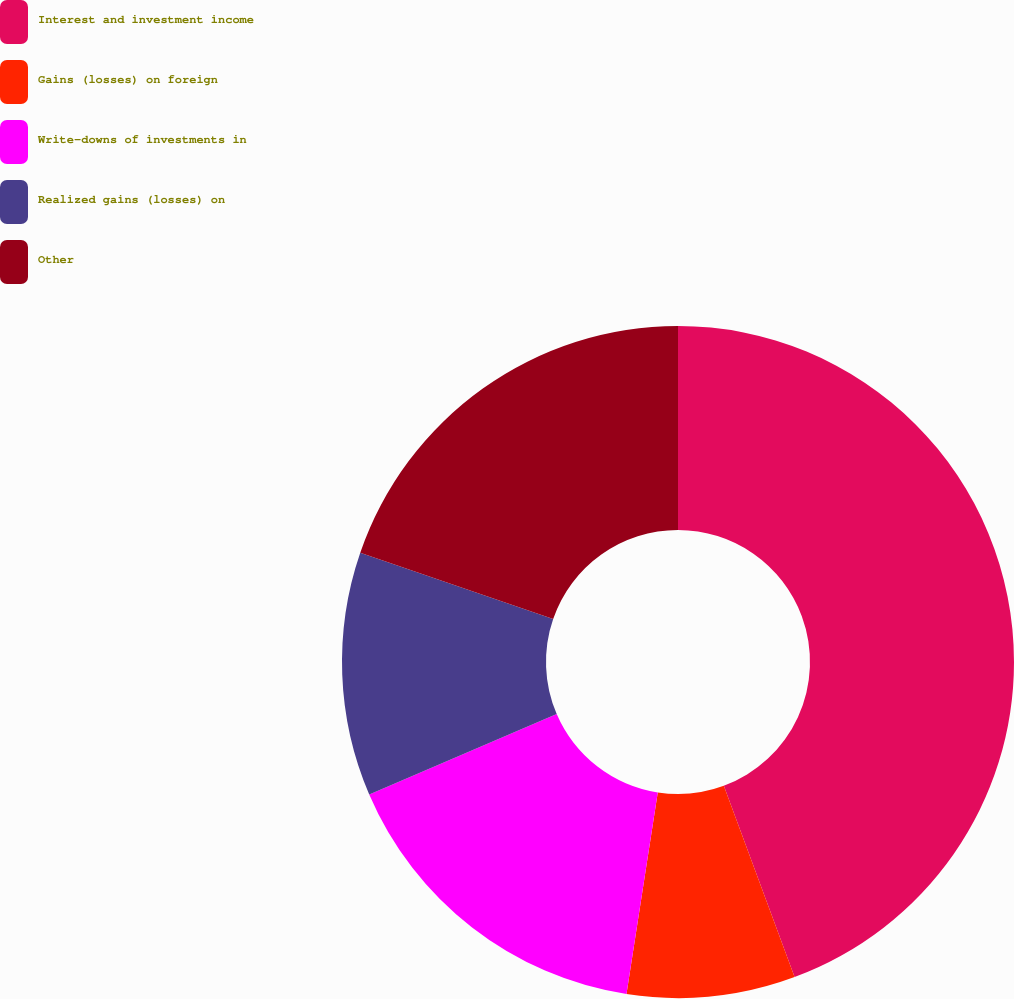Convert chart to OTSL. <chart><loc_0><loc_0><loc_500><loc_500><pie_chart><fcel>Interest and investment income<fcel>Gains (losses) on foreign<fcel>Write-downs of investments in<fcel>Realized gains (losses) on<fcel>Other<nl><fcel>44.36%<fcel>8.09%<fcel>16.1%<fcel>11.72%<fcel>19.73%<nl></chart> 